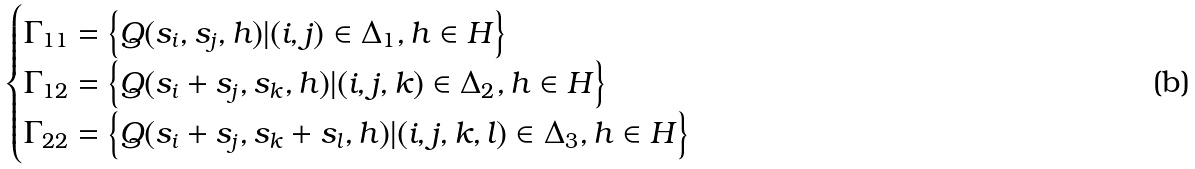<formula> <loc_0><loc_0><loc_500><loc_500>\begin{cases} \Gamma _ { 1 1 } = \left \{ Q ( s _ { i } , s _ { j } , h ) | ( i , j ) \in \Delta _ { 1 } , h \in H \right \} \\ \Gamma _ { 1 2 } = \left \{ Q ( s _ { i } + s _ { j } , s _ { k } , h ) | ( i , j , k ) \in \Delta _ { 2 } , h \in H \right \} \\ \Gamma _ { 2 2 } = \left \{ Q ( s _ { i } + s _ { j } , s _ { k } + s _ { l } , h ) | ( i , j , k , l ) \in \Delta _ { 3 } , h \in H \right \} \end{cases}</formula> 